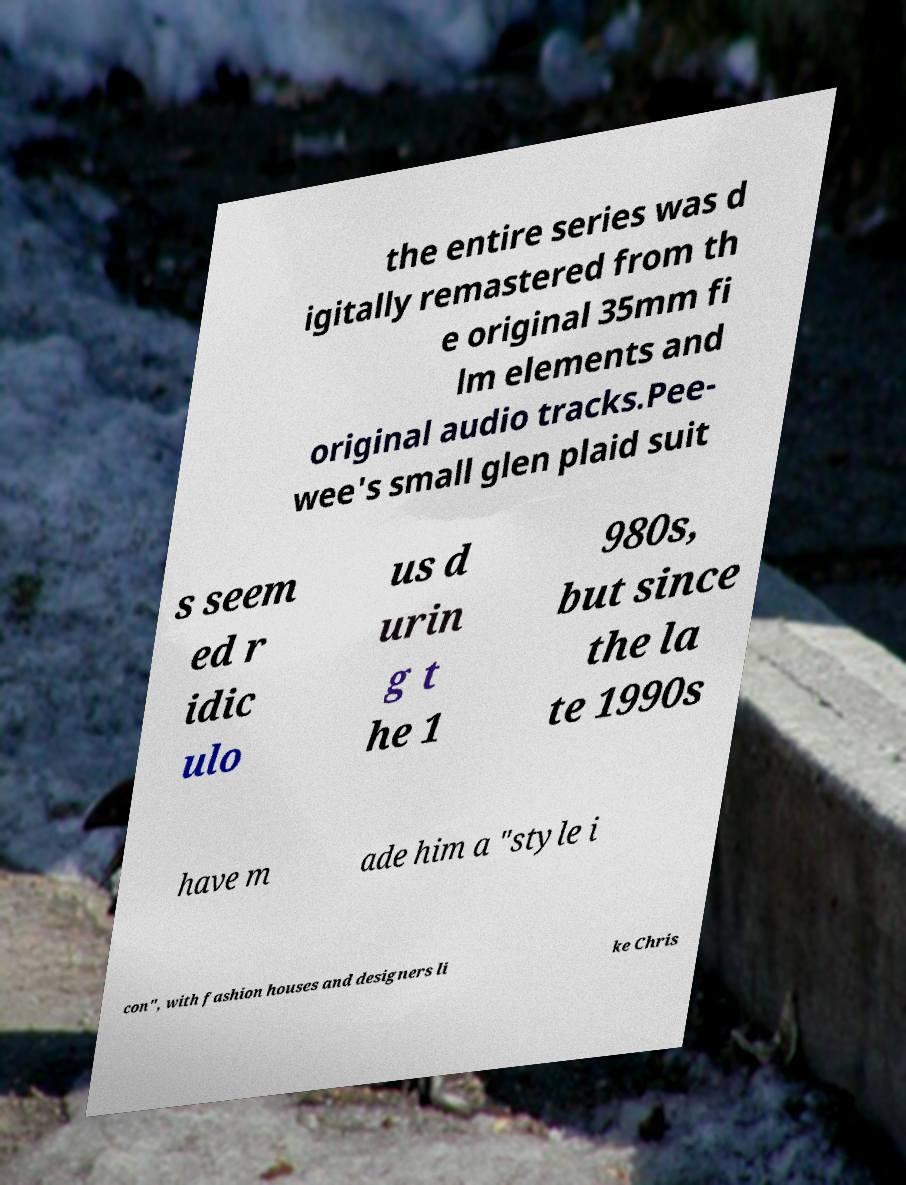Please read and relay the text visible in this image. What does it say? the entire series was d igitally remastered from th e original 35mm fi lm elements and original audio tracks.Pee- wee's small glen plaid suit s seem ed r idic ulo us d urin g t he 1 980s, but since the la te 1990s have m ade him a "style i con", with fashion houses and designers li ke Chris 